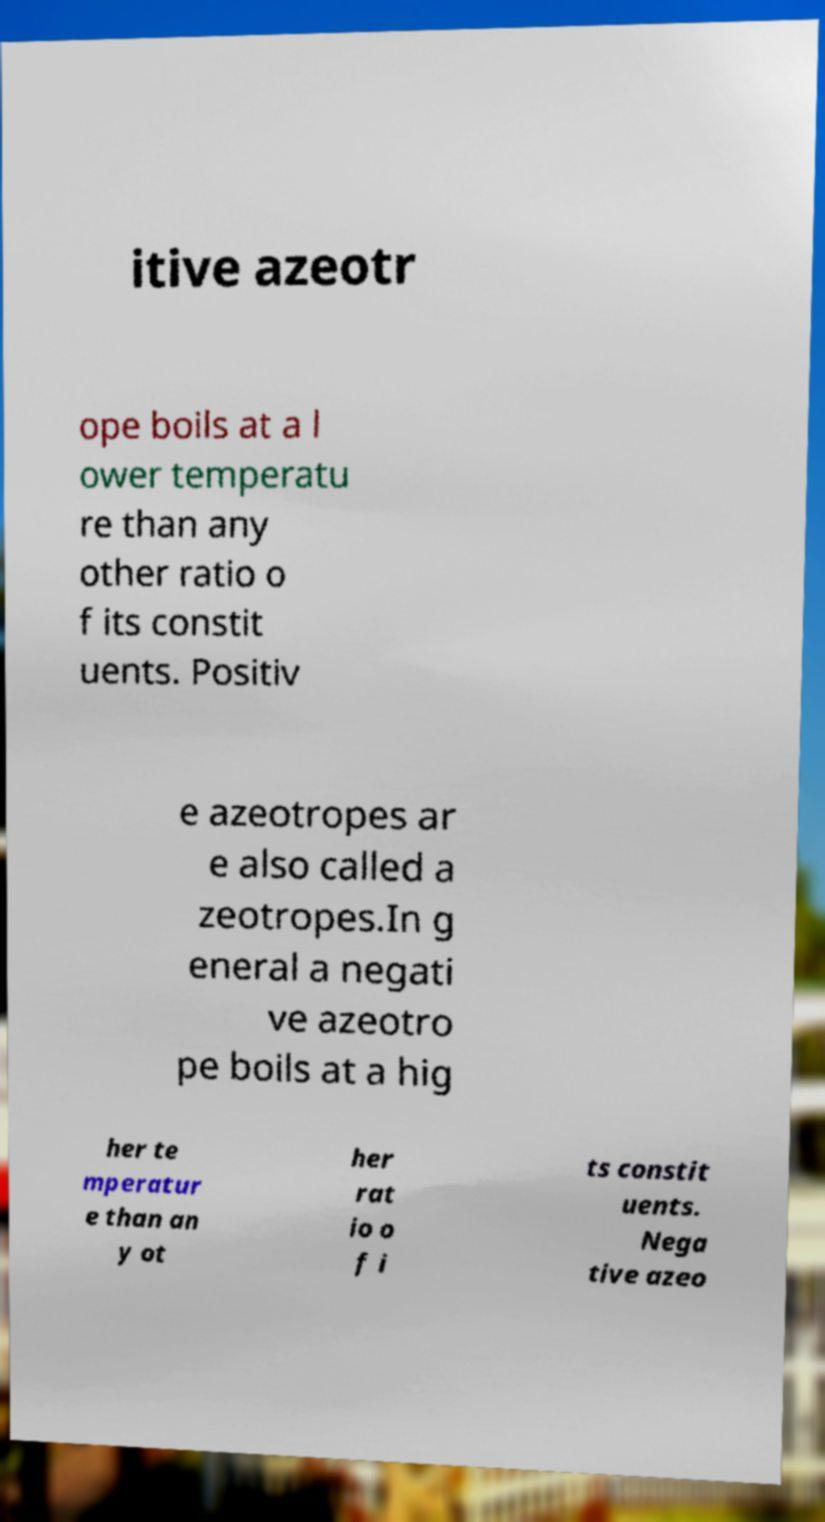Please identify and transcribe the text found in this image. itive azeotr ope boils at a l ower temperatu re than any other ratio o f its constit uents. Positiv e azeotropes ar e also called a zeotropes.In g eneral a negati ve azeotro pe boils at a hig her te mperatur e than an y ot her rat io o f i ts constit uents. Nega tive azeo 